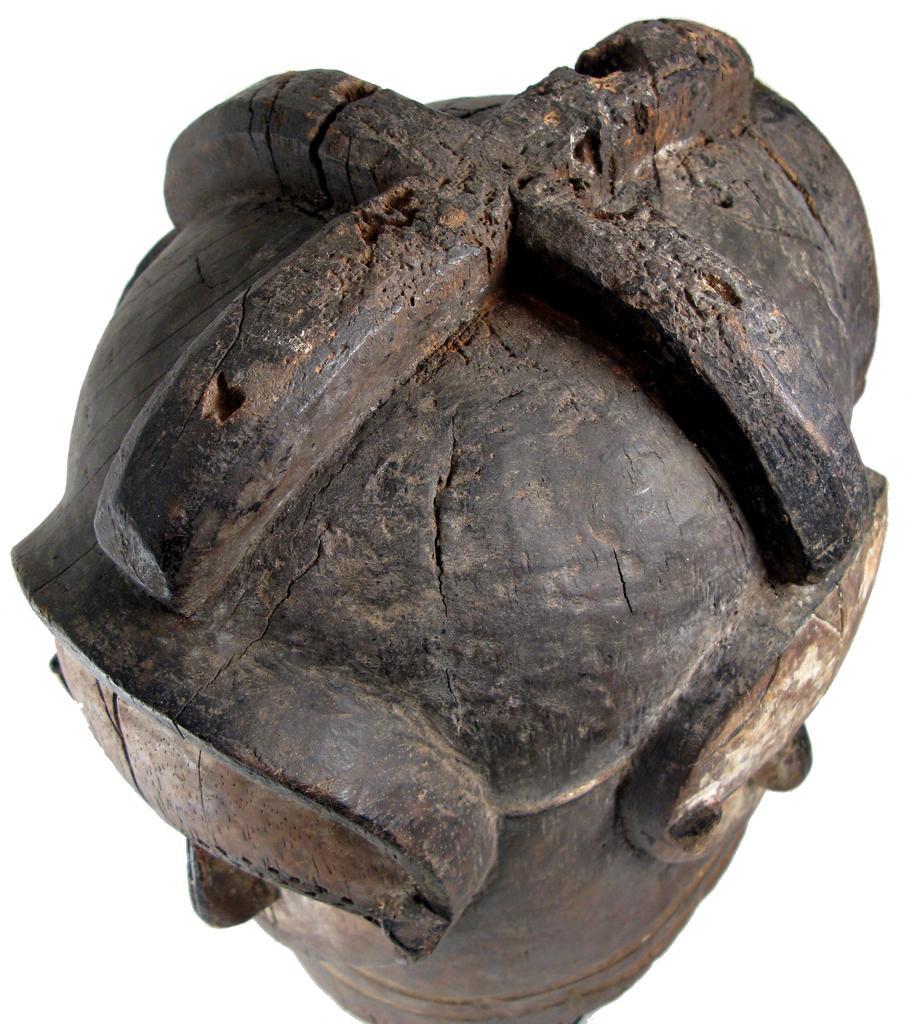In one or two sentences, can you explain what this image depicts? In this image I can see a wooden object which is in brown color and I can see white color background. 